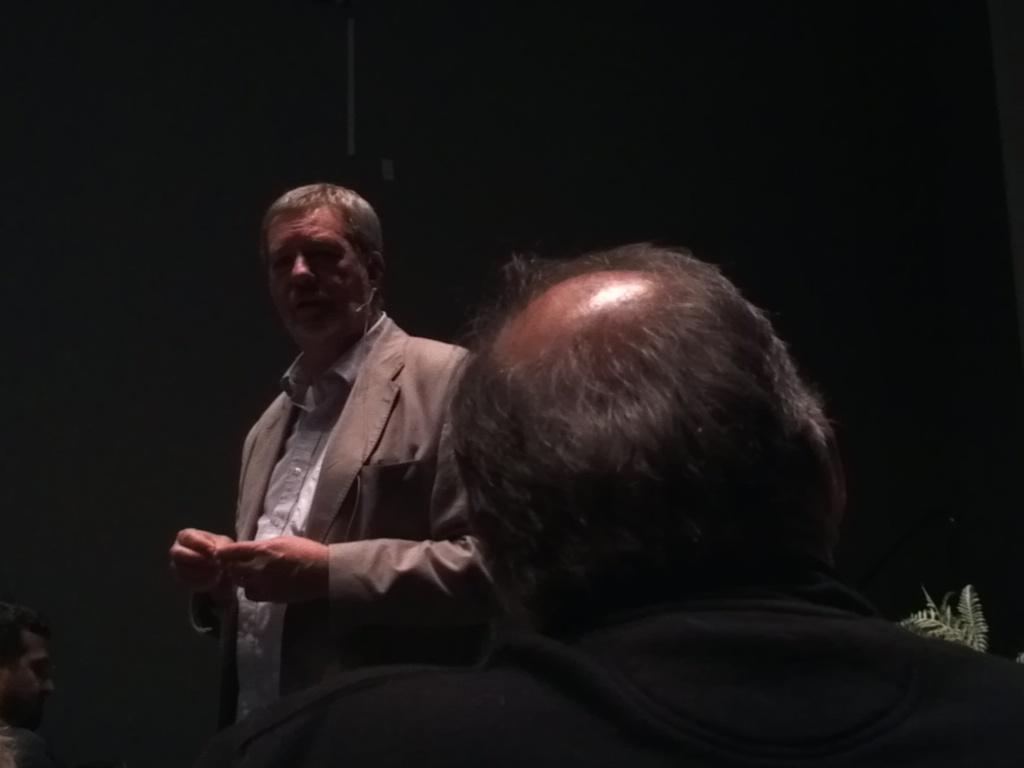Can you describe this image briefly? In the foreground of this picture, there is a man in black colored coat and in the background, there is another man standing in cream coat and we can also see a person's face and a plant. 